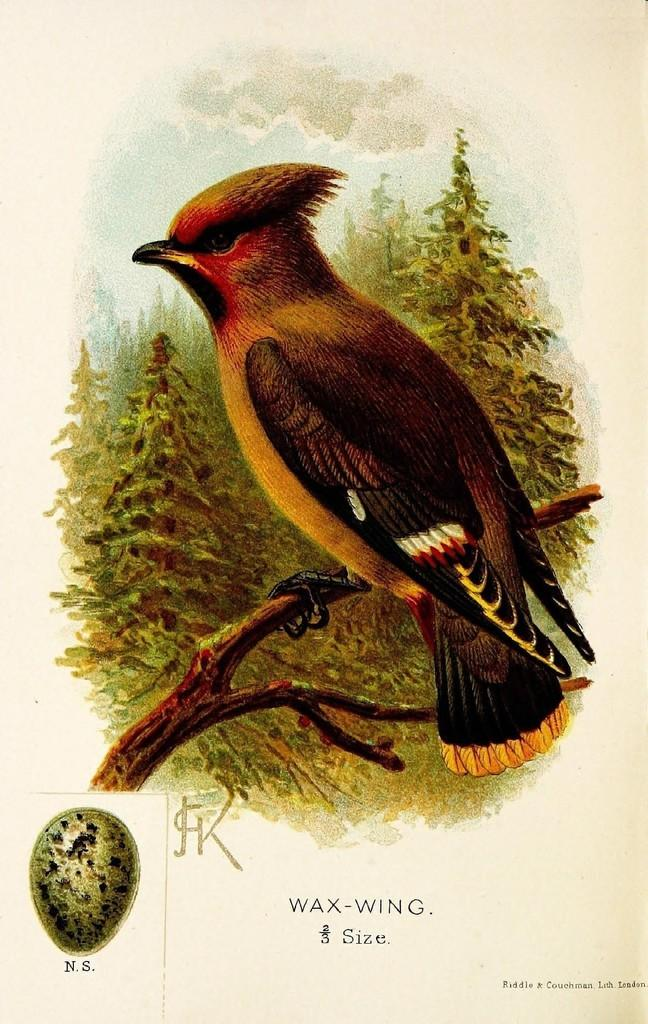What is depicted on the poster in the image? There is a poster in the image, and it features a bird on a branch. What can be found at the bottom of the poster? There is text and a logo at the bottom of the poster. What is visible in the background of the poster? There are trees in the background of the poster. How many toes does the bird have in the image? There is no way to determine the number of toes the bird has in the image, as the image only shows the bird on a branch and not its feet. 